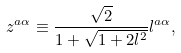Convert formula to latex. <formula><loc_0><loc_0><loc_500><loc_500>z ^ { a \alpha } \equiv \frac { \sqrt { 2 } } { 1 + \sqrt { 1 + 2 l ^ { 2 } } } l ^ { a \alpha } ,</formula> 